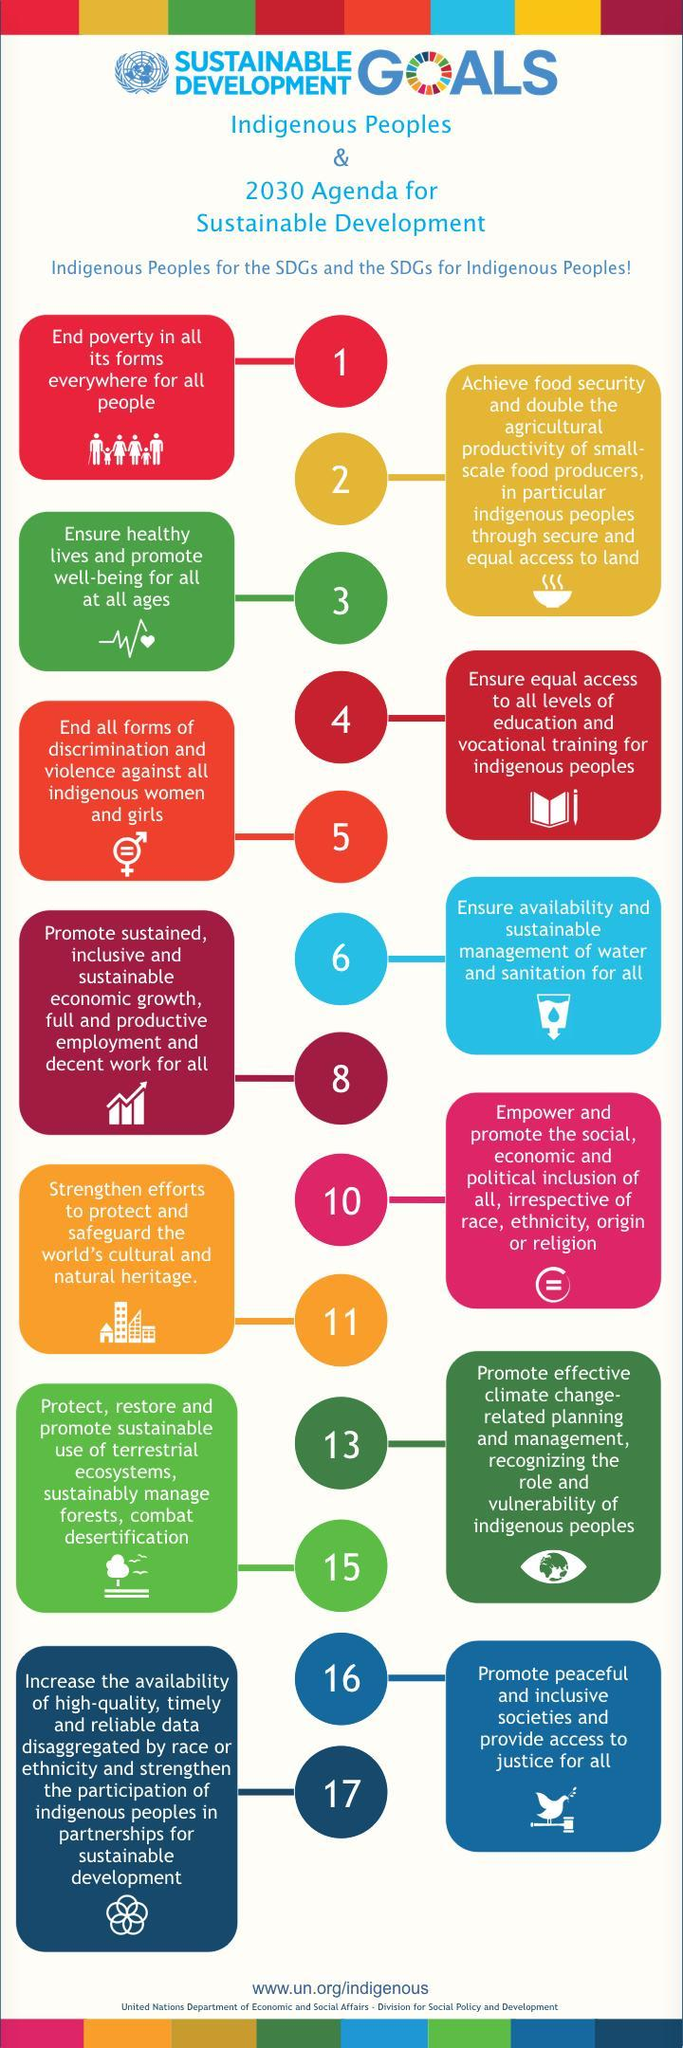What symbol indicates point no: 2, bowl or book
Answer the question with a short phrase. bowl which points talks about sanitation 6 